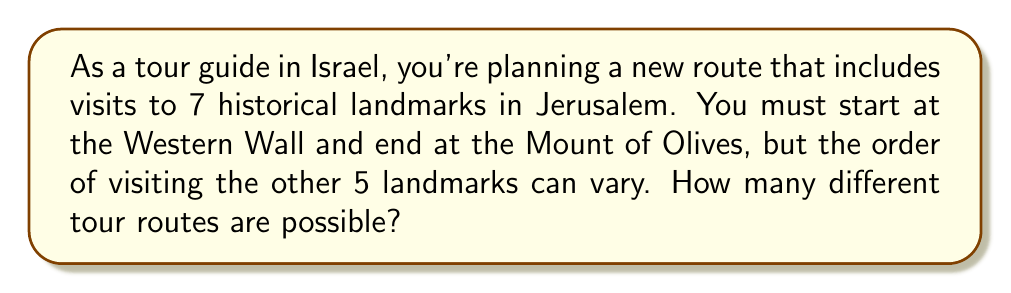Give your solution to this math problem. To solve this problem, we can use the concept of permutations from discrete mathematics. Let's break it down step-by-step:

1. We have 7 landmarks in total.
2. The starting point (Western Wall) and ending point (Mount of Olives) are fixed.
3. We need to determine the number of ways to arrange the remaining 5 landmarks.

This is a perfect scenario for using the permutation formula. The number of permutations of n distinct objects is given by:

$$P(n) = n!$$

where $n!$ represents the factorial of $n$.

In our case, we have 5 landmarks that can be arranged in any order. Therefore:

$$\text{Number of possible routes} = P(5) = 5!$$

Now, let's calculate 5!:

$$5! = 5 \times 4 \times 3 \times 2 \times 1 = 120$$

Thus, there are 120 different ways to arrange the 5 landmarks between the fixed starting and ending points.
Answer: 120 different tour routes 